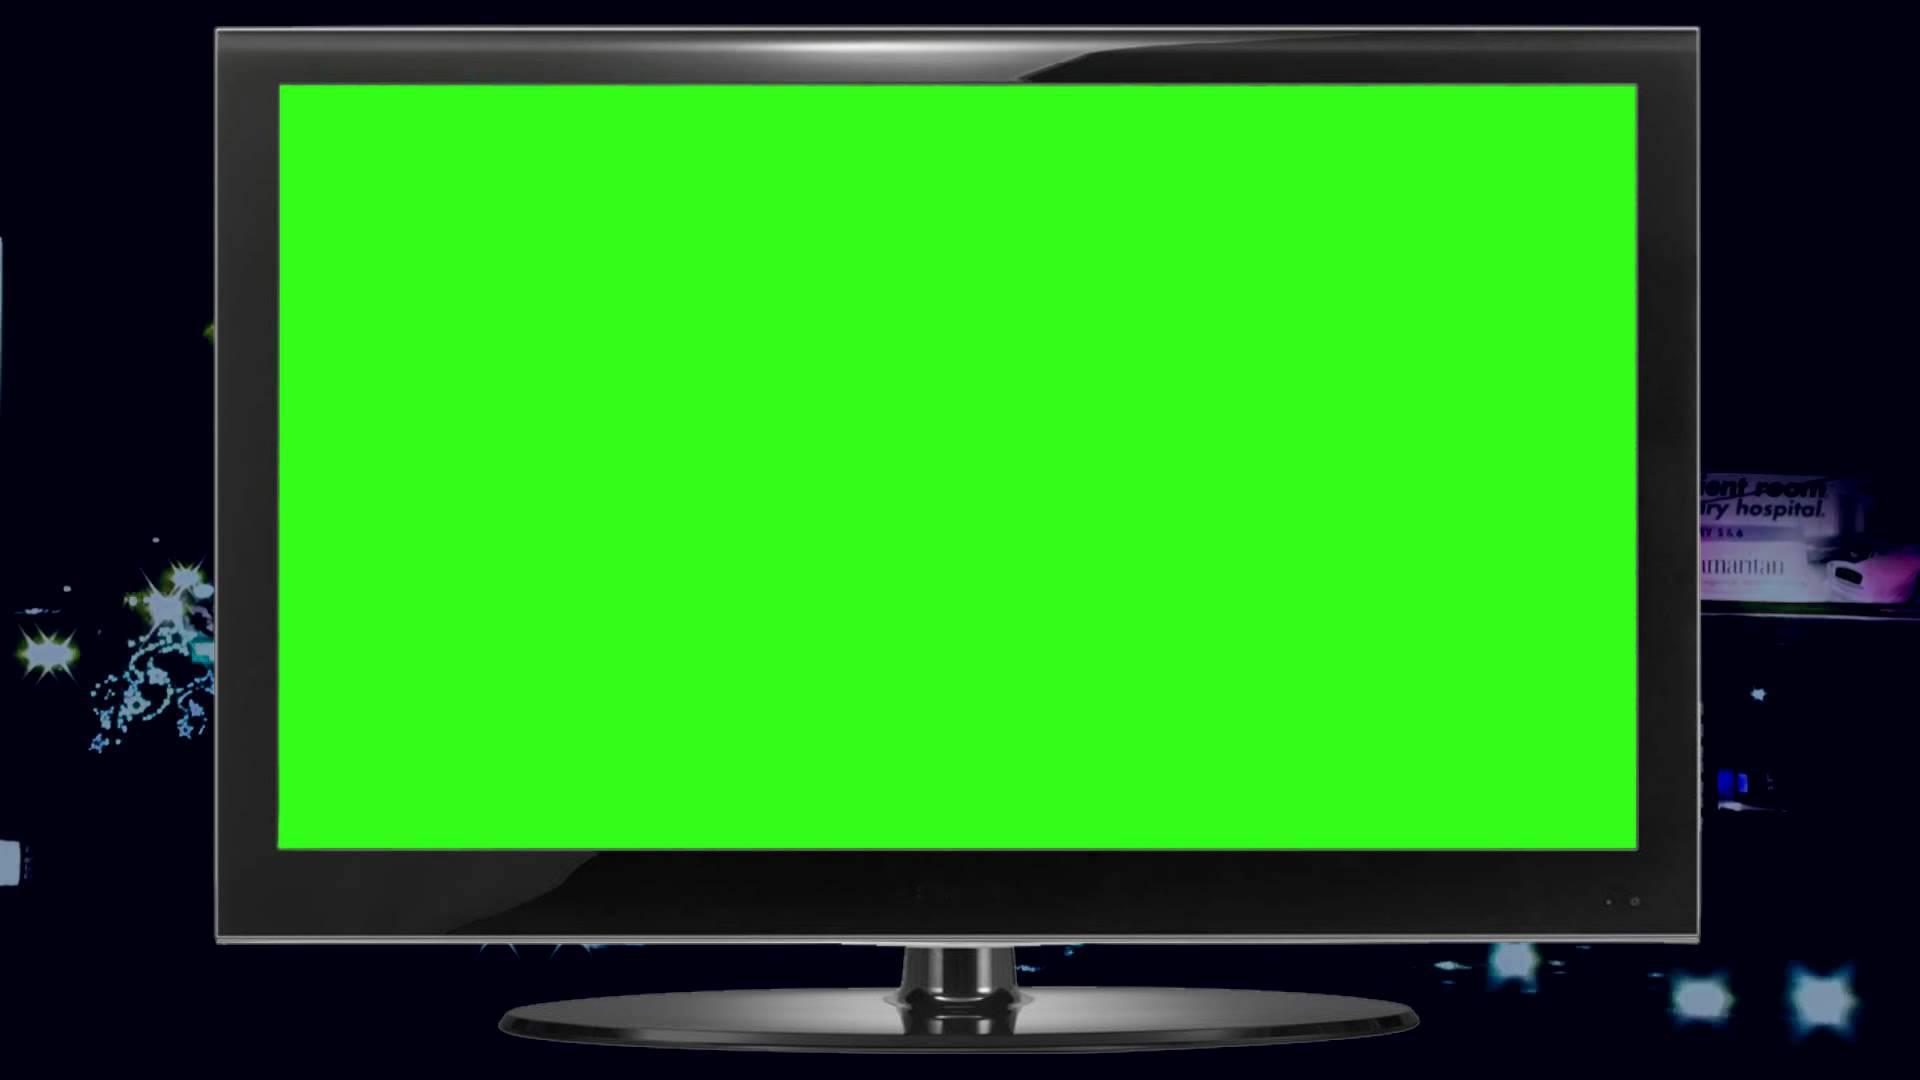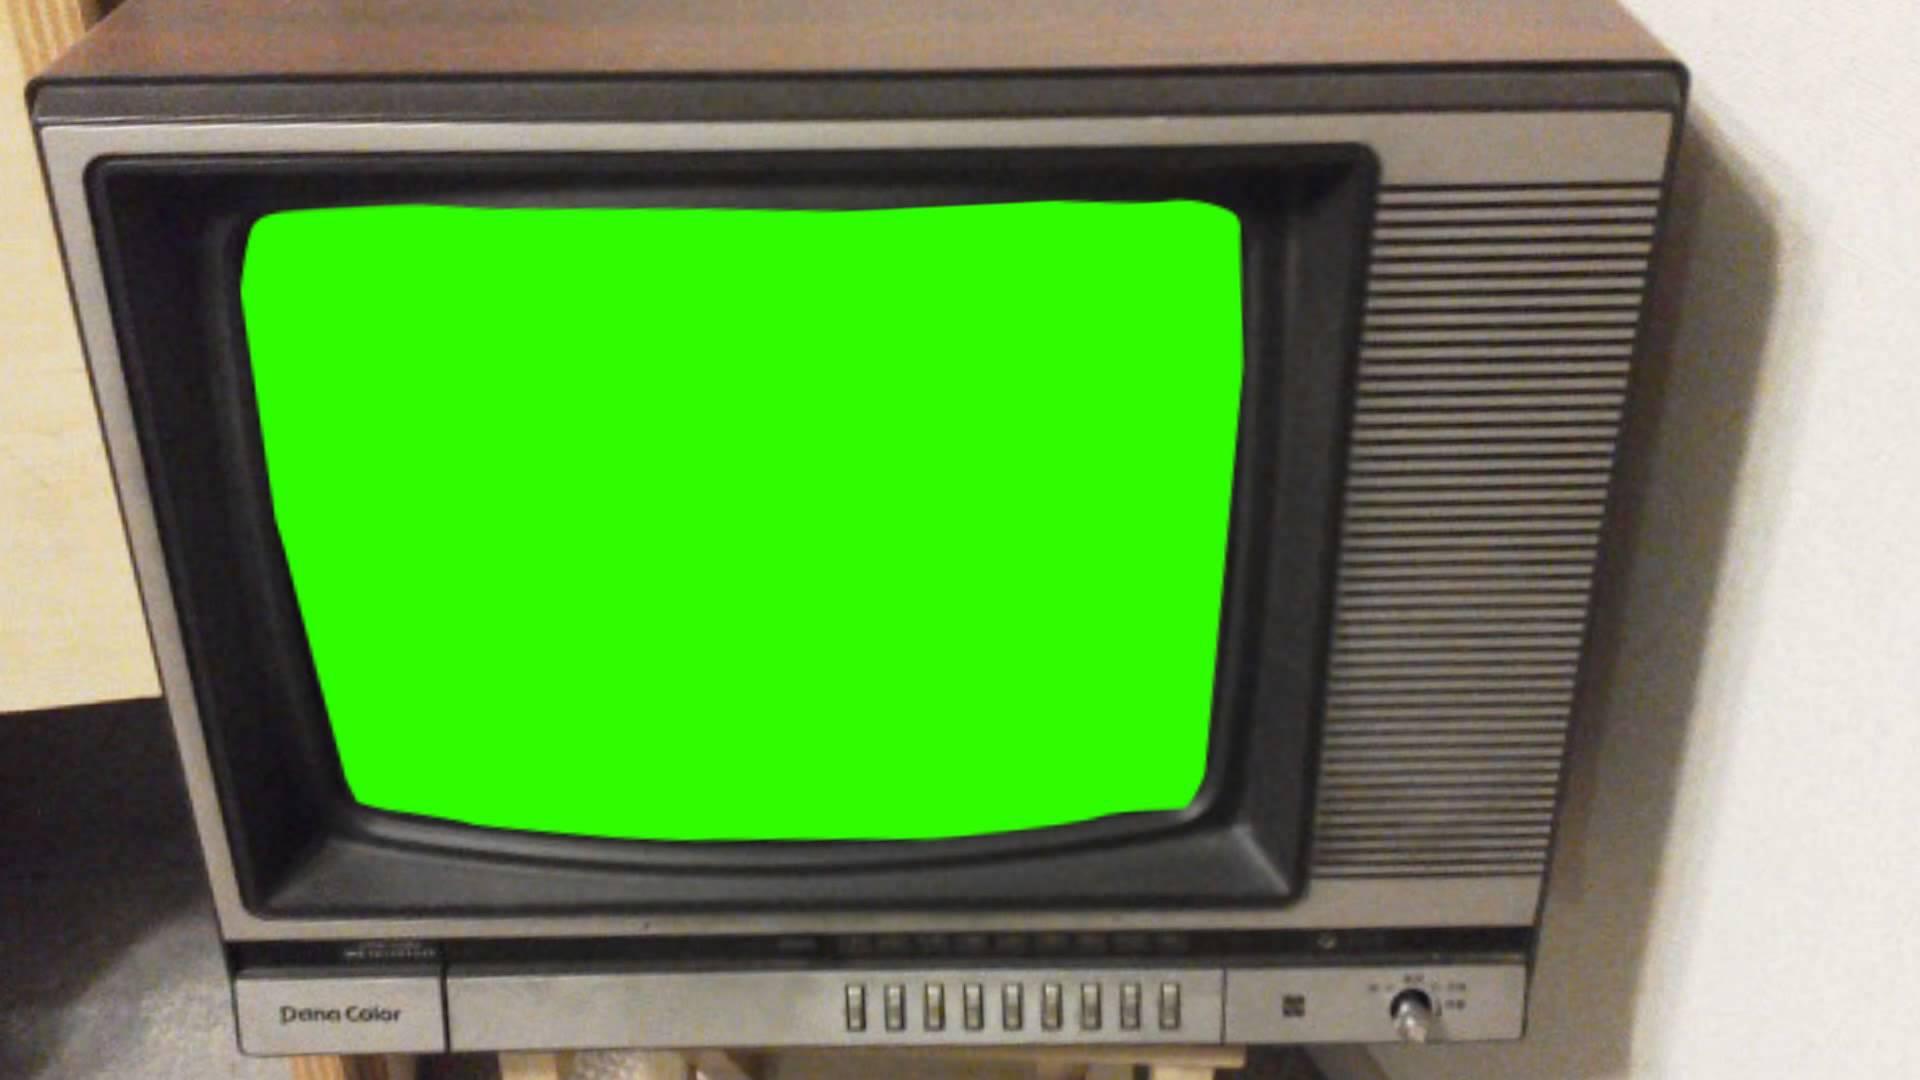The first image is the image on the left, the second image is the image on the right. For the images shown, is this caption "One glowing green TV screen is modern, flat and wide, and the other glowing green screen is in an old-fashioned box-like TV set." true? Answer yes or no. Yes. 